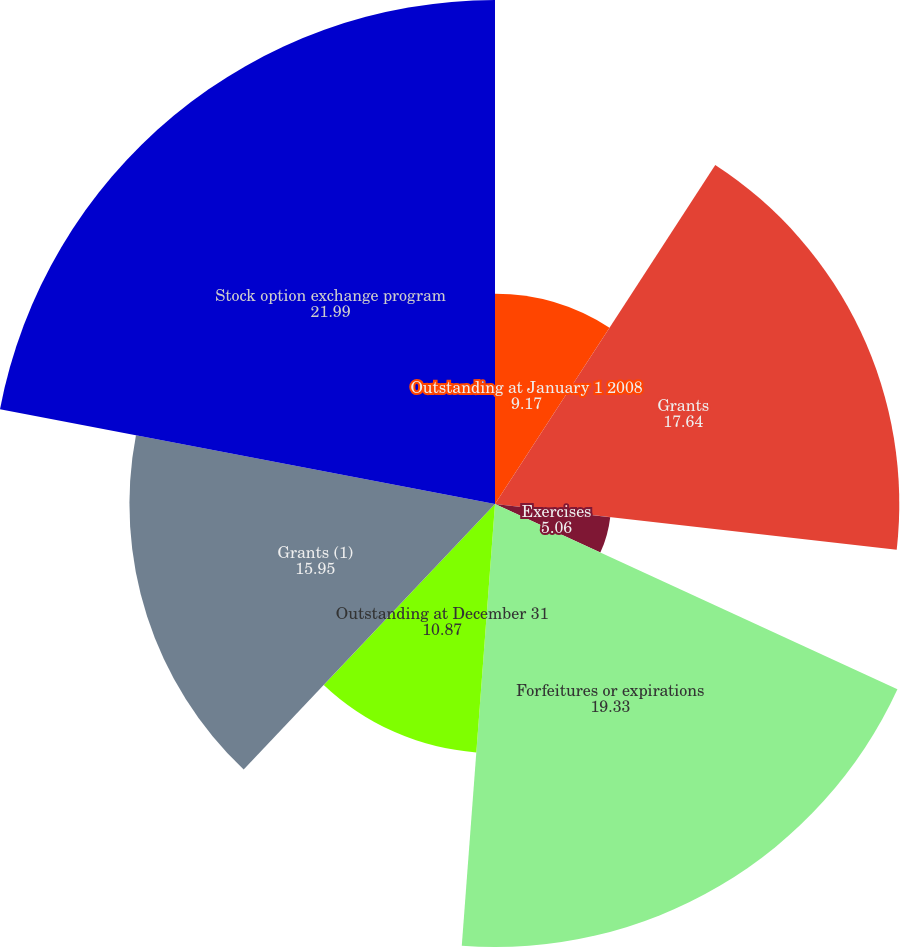Convert chart. <chart><loc_0><loc_0><loc_500><loc_500><pie_chart><fcel>Outstanding at January 1 2008<fcel>Grants<fcel>Exercises<fcel>Forfeitures or expirations<fcel>Outstanding at December 31<fcel>Grants (1)<fcel>Stock option exchange program<nl><fcel>9.17%<fcel>17.64%<fcel>5.06%<fcel>19.33%<fcel>10.87%<fcel>15.95%<fcel>21.99%<nl></chart> 